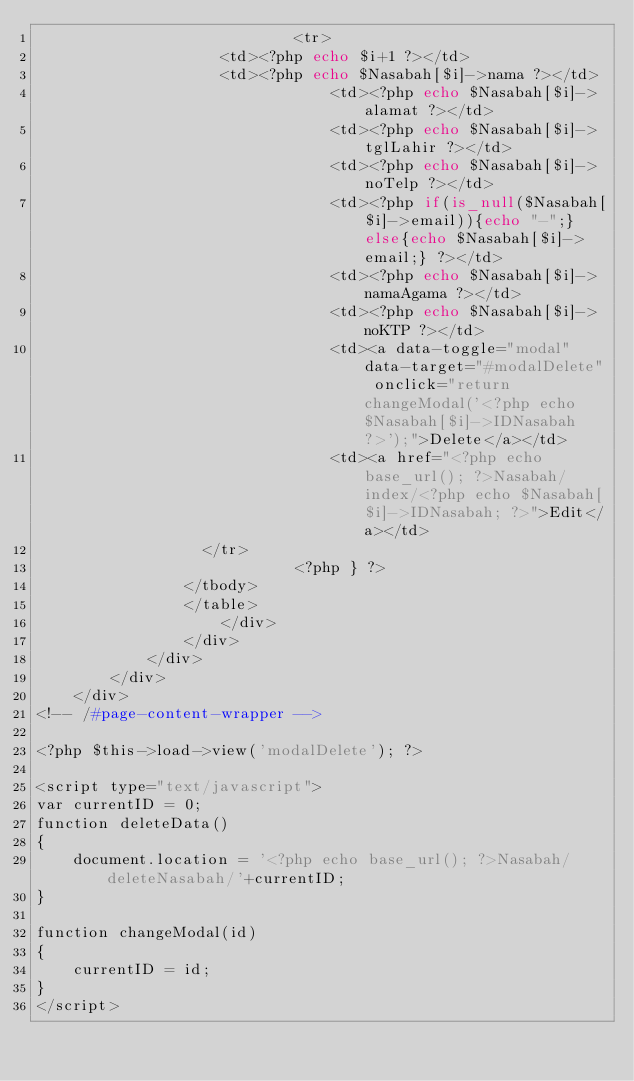<code> <loc_0><loc_0><loc_500><loc_500><_PHP_>                            <tr>
        						<td><?php echo $i+1 ?></td>
        						<td><?php echo $Nasabah[$i]->nama ?></td>  
                                <td><?php echo $Nasabah[$i]->alamat ?></td> 
                                <td><?php echo $Nasabah[$i]->tglLahir ?></td> 
                                <td><?php echo $Nasabah[$i]->noTelp ?></td>  
                                <td><?php if(is_null($Nasabah[$i]->email)){echo "-";}else{echo $Nasabah[$i]->email;} ?></td> 
                                <td><?php echo $Nasabah[$i]->namaAgama ?></td> 
                                <td><?php echo $Nasabah[$i]->noKTP ?></td> 
                                <td><a data-toggle="modal" data-target="#modalDelete" onclick="return changeModal('<?php echo $Nasabah[$i]->IDNasabah ?>');">Delete</a></td>
                                <td><a href="<?php echo base_url(); ?>Nasabah/index/<?php echo $Nasabah[$i]->IDNasabah; ?>">Edit</a></td>
        					</tr>
                            <?php } ?>
        				</tbody>
        				</table>
                    </div>
                </div>
            </div>
        </div>
    </div>
<!-- /#page-content-wrapper -->

<?php $this->load->view('modalDelete'); ?>

<script type="text/javascript">
var currentID = 0;
function deleteData()
{
    document.location = '<?php echo base_url(); ?>Nasabah/deleteNasabah/'+currentID;
}

function changeModal(id)
{
    currentID = id;
}
</script>
</code> 